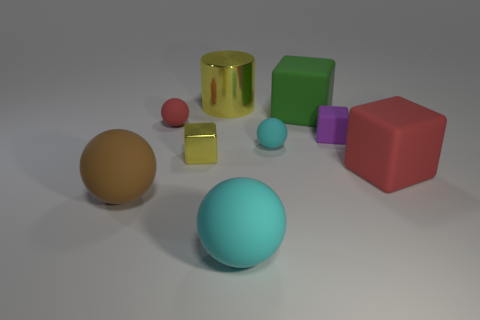There is a shiny object that is the same color as the tiny metallic cube; what size is it?
Provide a short and direct response. Large. There is a big object that is the same color as the shiny cube; what is its shape?
Provide a short and direct response. Cylinder. Is the number of large green cubes that are behind the yellow shiny cylinder less than the number of big green matte blocks?
Provide a short and direct response. Yes. What is the large yellow cylinder made of?
Your answer should be very brief. Metal. What is the color of the big cylinder?
Ensure brevity in your answer.  Yellow. There is a matte ball that is on the right side of the small red thing and in front of the tiny shiny cube; what is its color?
Give a very brief answer. Cyan. Is the material of the large cylinder the same as the yellow thing that is on the left side of the large metallic cylinder?
Offer a very short reply. Yes. There is a cyan thing on the right side of the cyan matte object that is in front of the large brown rubber thing; what is its size?
Give a very brief answer. Small. Is there any other thing that is the same color as the metallic block?
Keep it short and to the point. Yes. Does the red object that is to the left of the yellow cylinder have the same material as the yellow cylinder to the left of the red block?
Your answer should be compact. No. 